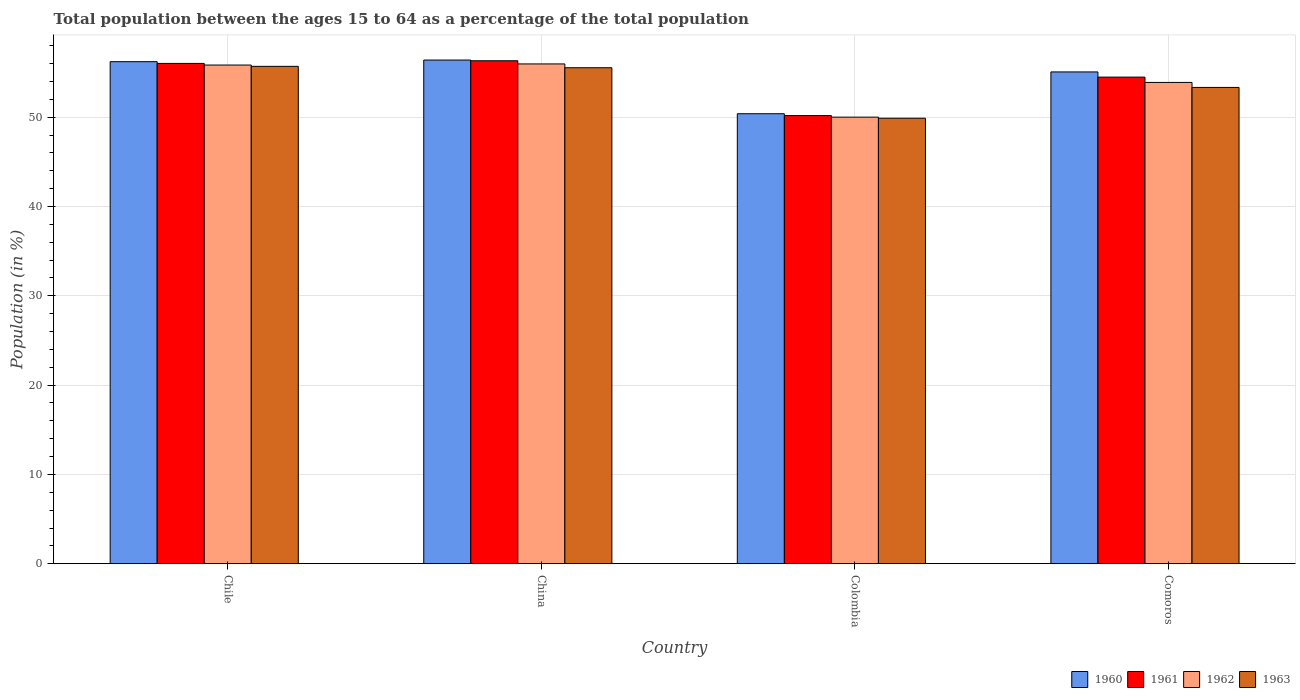How many bars are there on the 3rd tick from the left?
Make the answer very short. 4. What is the label of the 4th group of bars from the left?
Make the answer very short. Comoros. In how many cases, is the number of bars for a given country not equal to the number of legend labels?
Provide a short and direct response. 0. What is the percentage of the population ages 15 to 64 in 1963 in Colombia?
Make the answer very short. 49.88. Across all countries, what is the maximum percentage of the population ages 15 to 64 in 1961?
Your response must be concise. 56.32. Across all countries, what is the minimum percentage of the population ages 15 to 64 in 1962?
Your response must be concise. 50. In which country was the percentage of the population ages 15 to 64 in 1960 maximum?
Ensure brevity in your answer.  China. In which country was the percentage of the population ages 15 to 64 in 1962 minimum?
Give a very brief answer. Colombia. What is the total percentage of the population ages 15 to 64 in 1962 in the graph?
Keep it short and to the point. 215.69. What is the difference between the percentage of the population ages 15 to 64 in 1960 in Chile and that in Colombia?
Offer a very short reply. 5.83. What is the difference between the percentage of the population ages 15 to 64 in 1962 in Comoros and the percentage of the population ages 15 to 64 in 1960 in Chile?
Ensure brevity in your answer.  -2.32. What is the average percentage of the population ages 15 to 64 in 1960 per country?
Your answer should be very brief. 54.51. What is the difference between the percentage of the population ages 15 to 64 of/in 1960 and percentage of the population ages 15 to 64 of/in 1962 in Chile?
Provide a short and direct response. 0.38. In how many countries, is the percentage of the population ages 15 to 64 in 1962 greater than 4?
Offer a very short reply. 4. What is the ratio of the percentage of the population ages 15 to 64 in 1962 in Chile to that in Comoros?
Your answer should be compact. 1.04. Is the percentage of the population ages 15 to 64 in 1963 in Chile less than that in Comoros?
Your answer should be very brief. No. What is the difference between the highest and the second highest percentage of the population ages 15 to 64 in 1960?
Offer a terse response. 0.18. What is the difference between the highest and the lowest percentage of the population ages 15 to 64 in 1960?
Provide a succinct answer. 6.01. Is it the case that in every country, the sum of the percentage of the population ages 15 to 64 in 1962 and percentage of the population ages 15 to 64 in 1961 is greater than the sum of percentage of the population ages 15 to 64 in 1960 and percentage of the population ages 15 to 64 in 1963?
Your answer should be compact. No. What does the 1st bar from the left in Colombia represents?
Offer a very short reply. 1960. Is it the case that in every country, the sum of the percentage of the population ages 15 to 64 in 1960 and percentage of the population ages 15 to 64 in 1962 is greater than the percentage of the population ages 15 to 64 in 1963?
Offer a very short reply. Yes. How many bars are there?
Offer a terse response. 16. Are all the bars in the graph horizontal?
Offer a terse response. No. Does the graph contain any zero values?
Provide a succinct answer. No. How many legend labels are there?
Your response must be concise. 4. What is the title of the graph?
Offer a terse response. Total population between the ages 15 to 64 as a percentage of the total population. Does "1991" appear as one of the legend labels in the graph?
Your answer should be very brief. No. What is the Population (in %) of 1960 in Chile?
Offer a very short reply. 56.21. What is the Population (in %) in 1961 in Chile?
Offer a terse response. 56.02. What is the Population (in %) in 1962 in Chile?
Keep it short and to the point. 55.84. What is the Population (in %) in 1963 in Chile?
Provide a short and direct response. 55.69. What is the Population (in %) of 1960 in China?
Make the answer very short. 56.39. What is the Population (in %) in 1961 in China?
Ensure brevity in your answer.  56.32. What is the Population (in %) of 1962 in China?
Give a very brief answer. 55.96. What is the Population (in %) of 1963 in China?
Offer a terse response. 55.54. What is the Population (in %) of 1960 in Colombia?
Provide a short and direct response. 50.39. What is the Population (in %) of 1961 in Colombia?
Offer a very short reply. 50.18. What is the Population (in %) of 1962 in Colombia?
Offer a very short reply. 50. What is the Population (in %) of 1963 in Colombia?
Provide a short and direct response. 49.88. What is the Population (in %) of 1960 in Comoros?
Ensure brevity in your answer.  55.07. What is the Population (in %) in 1961 in Comoros?
Ensure brevity in your answer.  54.48. What is the Population (in %) of 1962 in Comoros?
Offer a terse response. 53.89. What is the Population (in %) in 1963 in Comoros?
Make the answer very short. 53.33. Across all countries, what is the maximum Population (in %) in 1960?
Provide a succinct answer. 56.39. Across all countries, what is the maximum Population (in %) of 1961?
Make the answer very short. 56.32. Across all countries, what is the maximum Population (in %) of 1962?
Your response must be concise. 55.96. Across all countries, what is the maximum Population (in %) in 1963?
Your response must be concise. 55.69. Across all countries, what is the minimum Population (in %) of 1960?
Keep it short and to the point. 50.39. Across all countries, what is the minimum Population (in %) in 1961?
Your answer should be compact. 50.18. Across all countries, what is the minimum Population (in %) of 1962?
Offer a very short reply. 50. Across all countries, what is the minimum Population (in %) in 1963?
Your answer should be very brief. 49.88. What is the total Population (in %) in 1960 in the graph?
Offer a very short reply. 218.06. What is the total Population (in %) in 1961 in the graph?
Your answer should be compact. 217. What is the total Population (in %) in 1962 in the graph?
Give a very brief answer. 215.69. What is the total Population (in %) of 1963 in the graph?
Provide a short and direct response. 214.44. What is the difference between the Population (in %) in 1960 in Chile and that in China?
Your answer should be very brief. -0.18. What is the difference between the Population (in %) in 1961 in Chile and that in China?
Your response must be concise. -0.3. What is the difference between the Population (in %) in 1962 in Chile and that in China?
Give a very brief answer. -0.13. What is the difference between the Population (in %) in 1963 in Chile and that in China?
Offer a terse response. 0.15. What is the difference between the Population (in %) of 1960 in Chile and that in Colombia?
Your answer should be compact. 5.83. What is the difference between the Population (in %) of 1961 in Chile and that in Colombia?
Make the answer very short. 5.84. What is the difference between the Population (in %) in 1962 in Chile and that in Colombia?
Make the answer very short. 5.83. What is the difference between the Population (in %) in 1963 in Chile and that in Colombia?
Offer a terse response. 5.81. What is the difference between the Population (in %) of 1960 in Chile and that in Comoros?
Keep it short and to the point. 1.15. What is the difference between the Population (in %) of 1961 in Chile and that in Comoros?
Your answer should be very brief. 1.53. What is the difference between the Population (in %) in 1962 in Chile and that in Comoros?
Your answer should be compact. 1.95. What is the difference between the Population (in %) of 1963 in Chile and that in Comoros?
Offer a terse response. 2.36. What is the difference between the Population (in %) in 1960 in China and that in Colombia?
Your response must be concise. 6.01. What is the difference between the Population (in %) in 1961 in China and that in Colombia?
Keep it short and to the point. 6.14. What is the difference between the Population (in %) of 1962 in China and that in Colombia?
Ensure brevity in your answer.  5.96. What is the difference between the Population (in %) of 1963 in China and that in Colombia?
Offer a terse response. 5.65. What is the difference between the Population (in %) of 1960 in China and that in Comoros?
Offer a terse response. 1.33. What is the difference between the Population (in %) in 1961 in China and that in Comoros?
Your answer should be compact. 1.83. What is the difference between the Population (in %) in 1962 in China and that in Comoros?
Your response must be concise. 2.07. What is the difference between the Population (in %) of 1963 in China and that in Comoros?
Your answer should be very brief. 2.21. What is the difference between the Population (in %) of 1960 in Colombia and that in Comoros?
Provide a succinct answer. -4.68. What is the difference between the Population (in %) of 1961 in Colombia and that in Comoros?
Keep it short and to the point. -4.31. What is the difference between the Population (in %) of 1962 in Colombia and that in Comoros?
Keep it short and to the point. -3.89. What is the difference between the Population (in %) in 1963 in Colombia and that in Comoros?
Your answer should be compact. -3.45. What is the difference between the Population (in %) of 1960 in Chile and the Population (in %) of 1961 in China?
Make the answer very short. -0.1. What is the difference between the Population (in %) in 1960 in Chile and the Population (in %) in 1962 in China?
Your response must be concise. 0.25. What is the difference between the Population (in %) of 1960 in Chile and the Population (in %) of 1963 in China?
Offer a terse response. 0.68. What is the difference between the Population (in %) in 1961 in Chile and the Population (in %) in 1962 in China?
Your answer should be very brief. 0.06. What is the difference between the Population (in %) in 1961 in Chile and the Population (in %) in 1963 in China?
Keep it short and to the point. 0.48. What is the difference between the Population (in %) in 1962 in Chile and the Population (in %) in 1963 in China?
Make the answer very short. 0.3. What is the difference between the Population (in %) of 1960 in Chile and the Population (in %) of 1961 in Colombia?
Offer a very short reply. 6.04. What is the difference between the Population (in %) in 1960 in Chile and the Population (in %) in 1962 in Colombia?
Give a very brief answer. 6.21. What is the difference between the Population (in %) in 1960 in Chile and the Population (in %) in 1963 in Colombia?
Your answer should be very brief. 6.33. What is the difference between the Population (in %) of 1961 in Chile and the Population (in %) of 1962 in Colombia?
Provide a short and direct response. 6.02. What is the difference between the Population (in %) of 1961 in Chile and the Population (in %) of 1963 in Colombia?
Offer a very short reply. 6.14. What is the difference between the Population (in %) of 1962 in Chile and the Population (in %) of 1963 in Colombia?
Provide a short and direct response. 5.96. What is the difference between the Population (in %) in 1960 in Chile and the Population (in %) in 1961 in Comoros?
Keep it short and to the point. 1.73. What is the difference between the Population (in %) in 1960 in Chile and the Population (in %) in 1962 in Comoros?
Give a very brief answer. 2.32. What is the difference between the Population (in %) of 1960 in Chile and the Population (in %) of 1963 in Comoros?
Offer a terse response. 2.88. What is the difference between the Population (in %) in 1961 in Chile and the Population (in %) in 1962 in Comoros?
Make the answer very short. 2.13. What is the difference between the Population (in %) in 1961 in Chile and the Population (in %) in 1963 in Comoros?
Your answer should be compact. 2.69. What is the difference between the Population (in %) in 1962 in Chile and the Population (in %) in 1963 in Comoros?
Ensure brevity in your answer.  2.51. What is the difference between the Population (in %) in 1960 in China and the Population (in %) in 1961 in Colombia?
Provide a short and direct response. 6.22. What is the difference between the Population (in %) of 1960 in China and the Population (in %) of 1962 in Colombia?
Your answer should be compact. 6.39. What is the difference between the Population (in %) in 1960 in China and the Population (in %) in 1963 in Colombia?
Your response must be concise. 6.51. What is the difference between the Population (in %) of 1961 in China and the Population (in %) of 1962 in Colombia?
Ensure brevity in your answer.  6.31. What is the difference between the Population (in %) of 1961 in China and the Population (in %) of 1963 in Colombia?
Provide a short and direct response. 6.44. What is the difference between the Population (in %) of 1962 in China and the Population (in %) of 1963 in Colombia?
Provide a short and direct response. 6.08. What is the difference between the Population (in %) in 1960 in China and the Population (in %) in 1961 in Comoros?
Offer a terse response. 1.91. What is the difference between the Population (in %) of 1960 in China and the Population (in %) of 1962 in Comoros?
Give a very brief answer. 2.5. What is the difference between the Population (in %) of 1960 in China and the Population (in %) of 1963 in Comoros?
Provide a short and direct response. 3.07. What is the difference between the Population (in %) in 1961 in China and the Population (in %) in 1962 in Comoros?
Offer a very short reply. 2.43. What is the difference between the Population (in %) in 1961 in China and the Population (in %) in 1963 in Comoros?
Provide a succinct answer. 2.99. What is the difference between the Population (in %) of 1962 in China and the Population (in %) of 1963 in Comoros?
Ensure brevity in your answer.  2.63. What is the difference between the Population (in %) in 1960 in Colombia and the Population (in %) in 1961 in Comoros?
Ensure brevity in your answer.  -4.1. What is the difference between the Population (in %) of 1960 in Colombia and the Population (in %) of 1962 in Comoros?
Offer a terse response. -3.5. What is the difference between the Population (in %) of 1960 in Colombia and the Population (in %) of 1963 in Comoros?
Your answer should be compact. -2.94. What is the difference between the Population (in %) of 1961 in Colombia and the Population (in %) of 1962 in Comoros?
Make the answer very short. -3.71. What is the difference between the Population (in %) of 1961 in Colombia and the Population (in %) of 1963 in Comoros?
Ensure brevity in your answer.  -3.15. What is the difference between the Population (in %) of 1962 in Colombia and the Population (in %) of 1963 in Comoros?
Ensure brevity in your answer.  -3.33. What is the average Population (in %) in 1960 per country?
Provide a short and direct response. 54.51. What is the average Population (in %) in 1961 per country?
Provide a succinct answer. 54.25. What is the average Population (in %) of 1962 per country?
Make the answer very short. 53.92. What is the average Population (in %) in 1963 per country?
Your answer should be very brief. 53.61. What is the difference between the Population (in %) of 1960 and Population (in %) of 1961 in Chile?
Your answer should be compact. 0.2. What is the difference between the Population (in %) in 1960 and Population (in %) in 1962 in Chile?
Keep it short and to the point. 0.38. What is the difference between the Population (in %) of 1960 and Population (in %) of 1963 in Chile?
Ensure brevity in your answer.  0.52. What is the difference between the Population (in %) in 1961 and Population (in %) in 1962 in Chile?
Your answer should be compact. 0.18. What is the difference between the Population (in %) in 1961 and Population (in %) in 1963 in Chile?
Your answer should be very brief. 0.33. What is the difference between the Population (in %) in 1962 and Population (in %) in 1963 in Chile?
Your answer should be very brief. 0.15. What is the difference between the Population (in %) of 1960 and Population (in %) of 1961 in China?
Make the answer very short. 0.08. What is the difference between the Population (in %) of 1960 and Population (in %) of 1962 in China?
Offer a very short reply. 0.43. What is the difference between the Population (in %) of 1960 and Population (in %) of 1963 in China?
Make the answer very short. 0.86. What is the difference between the Population (in %) of 1961 and Population (in %) of 1962 in China?
Provide a succinct answer. 0.35. What is the difference between the Population (in %) of 1961 and Population (in %) of 1963 in China?
Ensure brevity in your answer.  0.78. What is the difference between the Population (in %) of 1962 and Population (in %) of 1963 in China?
Give a very brief answer. 0.43. What is the difference between the Population (in %) in 1960 and Population (in %) in 1961 in Colombia?
Offer a terse response. 0.21. What is the difference between the Population (in %) of 1960 and Population (in %) of 1962 in Colombia?
Keep it short and to the point. 0.38. What is the difference between the Population (in %) in 1960 and Population (in %) in 1963 in Colombia?
Offer a very short reply. 0.5. What is the difference between the Population (in %) in 1961 and Population (in %) in 1962 in Colombia?
Keep it short and to the point. 0.17. What is the difference between the Population (in %) in 1961 and Population (in %) in 1963 in Colombia?
Provide a succinct answer. 0.3. What is the difference between the Population (in %) in 1962 and Population (in %) in 1963 in Colombia?
Keep it short and to the point. 0.12. What is the difference between the Population (in %) in 1960 and Population (in %) in 1961 in Comoros?
Provide a short and direct response. 0.58. What is the difference between the Population (in %) in 1960 and Population (in %) in 1962 in Comoros?
Give a very brief answer. 1.18. What is the difference between the Population (in %) of 1960 and Population (in %) of 1963 in Comoros?
Make the answer very short. 1.74. What is the difference between the Population (in %) in 1961 and Population (in %) in 1962 in Comoros?
Your answer should be compact. 0.59. What is the difference between the Population (in %) of 1961 and Population (in %) of 1963 in Comoros?
Make the answer very short. 1.15. What is the difference between the Population (in %) in 1962 and Population (in %) in 1963 in Comoros?
Provide a short and direct response. 0.56. What is the ratio of the Population (in %) of 1961 in Chile to that in China?
Provide a succinct answer. 0.99. What is the ratio of the Population (in %) of 1963 in Chile to that in China?
Your answer should be compact. 1. What is the ratio of the Population (in %) in 1960 in Chile to that in Colombia?
Provide a short and direct response. 1.12. What is the ratio of the Population (in %) of 1961 in Chile to that in Colombia?
Offer a very short reply. 1.12. What is the ratio of the Population (in %) of 1962 in Chile to that in Colombia?
Provide a short and direct response. 1.12. What is the ratio of the Population (in %) of 1963 in Chile to that in Colombia?
Provide a succinct answer. 1.12. What is the ratio of the Population (in %) of 1960 in Chile to that in Comoros?
Give a very brief answer. 1.02. What is the ratio of the Population (in %) in 1961 in Chile to that in Comoros?
Give a very brief answer. 1.03. What is the ratio of the Population (in %) in 1962 in Chile to that in Comoros?
Your answer should be very brief. 1.04. What is the ratio of the Population (in %) in 1963 in Chile to that in Comoros?
Your answer should be very brief. 1.04. What is the ratio of the Population (in %) in 1960 in China to that in Colombia?
Make the answer very short. 1.12. What is the ratio of the Population (in %) of 1961 in China to that in Colombia?
Your response must be concise. 1.12. What is the ratio of the Population (in %) of 1962 in China to that in Colombia?
Ensure brevity in your answer.  1.12. What is the ratio of the Population (in %) of 1963 in China to that in Colombia?
Ensure brevity in your answer.  1.11. What is the ratio of the Population (in %) in 1960 in China to that in Comoros?
Ensure brevity in your answer.  1.02. What is the ratio of the Population (in %) in 1961 in China to that in Comoros?
Your answer should be very brief. 1.03. What is the ratio of the Population (in %) of 1962 in China to that in Comoros?
Your answer should be very brief. 1.04. What is the ratio of the Population (in %) of 1963 in China to that in Comoros?
Offer a terse response. 1.04. What is the ratio of the Population (in %) in 1960 in Colombia to that in Comoros?
Give a very brief answer. 0.92. What is the ratio of the Population (in %) in 1961 in Colombia to that in Comoros?
Provide a succinct answer. 0.92. What is the ratio of the Population (in %) in 1962 in Colombia to that in Comoros?
Your response must be concise. 0.93. What is the ratio of the Population (in %) of 1963 in Colombia to that in Comoros?
Offer a terse response. 0.94. What is the difference between the highest and the second highest Population (in %) in 1960?
Offer a very short reply. 0.18. What is the difference between the highest and the second highest Population (in %) of 1961?
Your answer should be very brief. 0.3. What is the difference between the highest and the second highest Population (in %) in 1962?
Ensure brevity in your answer.  0.13. What is the difference between the highest and the second highest Population (in %) of 1963?
Provide a succinct answer. 0.15. What is the difference between the highest and the lowest Population (in %) in 1960?
Offer a very short reply. 6.01. What is the difference between the highest and the lowest Population (in %) in 1961?
Offer a terse response. 6.14. What is the difference between the highest and the lowest Population (in %) in 1962?
Ensure brevity in your answer.  5.96. What is the difference between the highest and the lowest Population (in %) of 1963?
Ensure brevity in your answer.  5.81. 